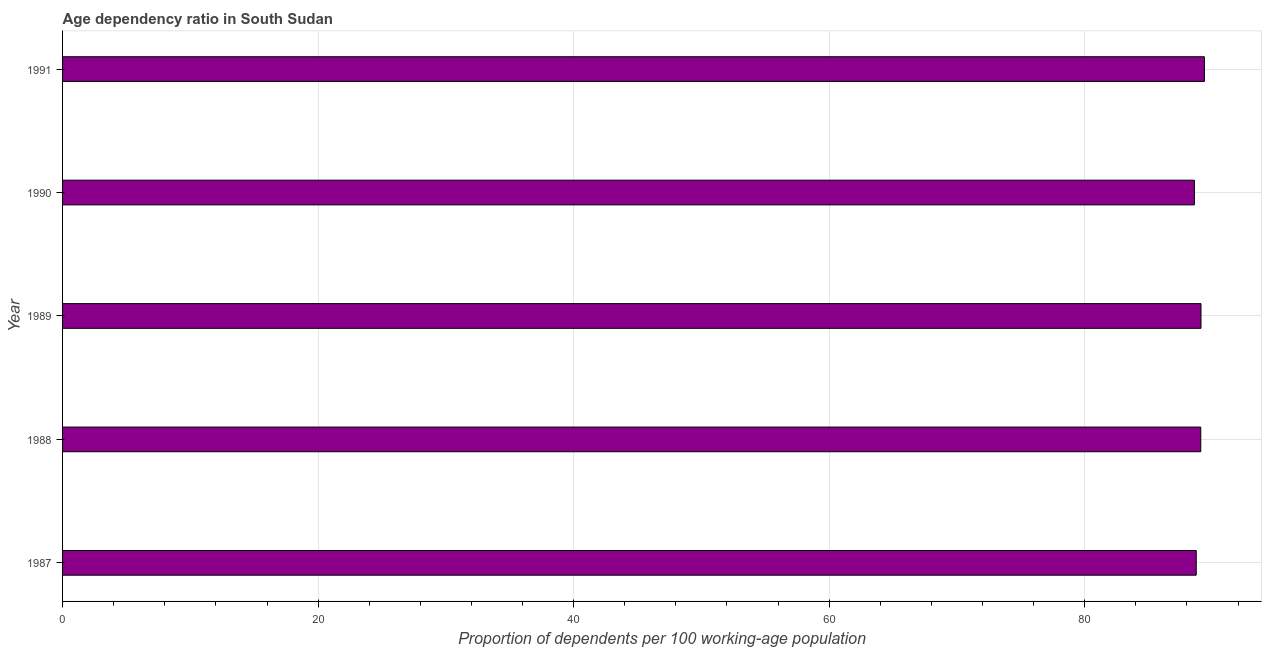Does the graph contain any zero values?
Give a very brief answer. No. Does the graph contain grids?
Give a very brief answer. Yes. What is the title of the graph?
Your response must be concise. Age dependency ratio in South Sudan. What is the label or title of the X-axis?
Provide a short and direct response. Proportion of dependents per 100 working-age population. What is the label or title of the Y-axis?
Your answer should be very brief. Year. What is the age dependency ratio in 1989?
Keep it short and to the point. 89.1. Across all years, what is the maximum age dependency ratio?
Your answer should be compact. 89.37. Across all years, what is the minimum age dependency ratio?
Offer a very short reply. 88.58. In which year was the age dependency ratio minimum?
Keep it short and to the point. 1990. What is the sum of the age dependency ratio?
Make the answer very short. 444.86. What is the difference between the age dependency ratio in 1987 and 1988?
Offer a terse response. -0.35. What is the average age dependency ratio per year?
Your answer should be compact. 88.97. What is the median age dependency ratio?
Keep it short and to the point. 89.08. Do a majority of the years between 1987 and 1988 (inclusive) have age dependency ratio greater than 52 ?
Keep it short and to the point. Yes. Is the age dependency ratio in 1988 less than that in 1991?
Make the answer very short. Yes. Is the difference between the age dependency ratio in 1987 and 1991 greater than the difference between any two years?
Your answer should be compact. No. What is the difference between the highest and the second highest age dependency ratio?
Offer a terse response. 0.27. What is the difference between the highest and the lowest age dependency ratio?
Your response must be concise. 0.78. In how many years, is the age dependency ratio greater than the average age dependency ratio taken over all years?
Keep it short and to the point. 3. How many bars are there?
Give a very brief answer. 5. Are all the bars in the graph horizontal?
Your answer should be very brief. Yes. How many years are there in the graph?
Provide a short and direct response. 5. Are the values on the major ticks of X-axis written in scientific E-notation?
Provide a short and direct response. No. What is the Proportion of dependents per 100 working-age population in 1987?
Your answer should be very brief. 88.73. What is the Proportion of dependents per 100 working-age population of 1988?
Your answer should be compact. 89.08. What is the Proportion of dependents per 100 working-age population in 1989?
Offer a very short reply. 89.1. What is the Proportion of dependents per 100 working-age population in 1990?
Keep it short and to the point. 88.58. What is the Proportion of dependents per 100 working-age population of 1991?
Offer a terse response. 89.37. What is the difference between the Proportion of dependents per 100 working-age population in 1987 and 1988?
Provide a short and direct response. -0.35. What is the difference between the Proportion of dependents per 100 working-age population in 1987 and 1989?
Offer a terse response. -0.37. What is the difference between the Proportion of dependents per 100 working-age population in 1987 and 1990?
Offer a terse response. 0.14. What is the difference between the Proportion of dependents per 100 working-age population in 1987 and 1991?
Your answer should be compact. -0.64. What is the difference between the Proportion of dependents per 100 working-age population in 1988 and 1989?
Provide a succinct answer. -0.02. What is the difference between the Proportion of dependents per 100 working-age population in 1988 and 1990?
Offer a terse response. 0.5. What is the difference between the Proportion of dependents per 100 working-age population in 1988 and 1991?
Offer a very short reply. -0.28. What is the difference between the Proportion of dependents per 100 working-age population in 1989 and 1990?
Offer a very short reply. 0.51. What is the difference between the Proportion of dependents per 100 working-age population in 1989 and 1991?
Provide a short and direct response. -0.27. What is the difference between the Proportion of dependents per 100 working-age population in 1990 and 1991?
Offer a terse response. -0.78. What is the ratio of the Proportion of dependents per 100 working-age population in 1987 to that in 1989?
Keep it short and to the point. 1. What is the ratio of the Proportion of dependents per 100 working-age population in 1988 to that in 1989?
Make the answer very short. 1. What is the ratio of the Proportion of dependents per 100 working-age population in 1988 to that in 1990?
Offer a very short reply. 1.01. What is the ratio of the Proportion of dependents per 100 working-age population in 1988 to that in 1991?
Your answer should be very brief. 1. What is the ratio of the Proportion of dependents per 100 working-age population in 1990 to that in 1991?
Offer a very short reply. 0.99. 